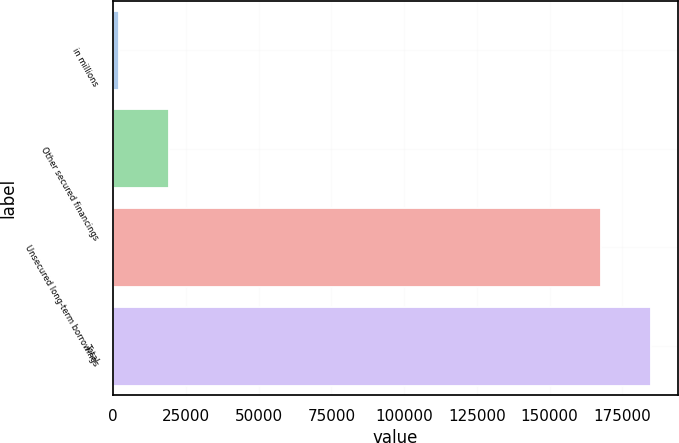Convert chart. <chart><loc_0><loc_0><loc_500><loc_500><bar_chart><fcel>in millions<fcel>Other secured financings<fcel>Unsecured long-term borrowings<fcel>Total<nl><fcel>2014<fcel>19294.6<fcel>167571<fcel>184852<nl></chart> 